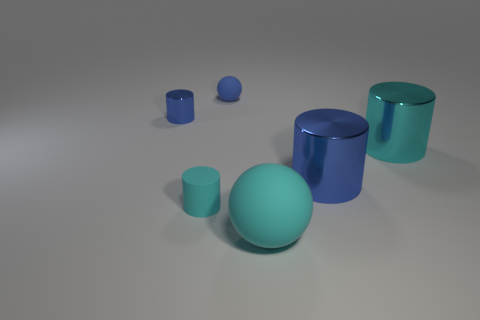Add 1 large cyan metal cylinders. How many objects exist? 7 Subtract all cylinders. How many objects are left? 2 Add 2 yellow metal spheres. How many yellow metal spheres exist? 2 Subtract 0 purple cylinders. How many objects are left? 6 Subtract all big matte spheres. Subtract all large rubber blocks. How many objects are left? 5 Add 2 metal cylinders. How many metal cylinders are left? 5 